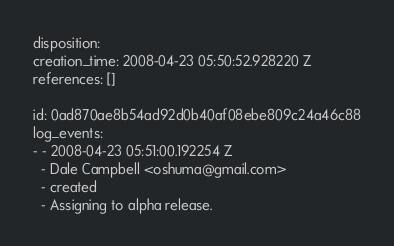<code> <loc_0><loc_0><loc_500><loc_500><_YAML_>disposition: 
creation_time: 2008-04-23 05:50:52.928220 Z
references: []

id: 0ad870ae8b54ad92d0b40af08ebe809c24a46c88
log_events: 
- - 2008-04-23 05:51:00.192254 Z
  - Dale Campbell <oshuma@gmail.com>
  - created
  - Assigning to alpha release.
</code> 